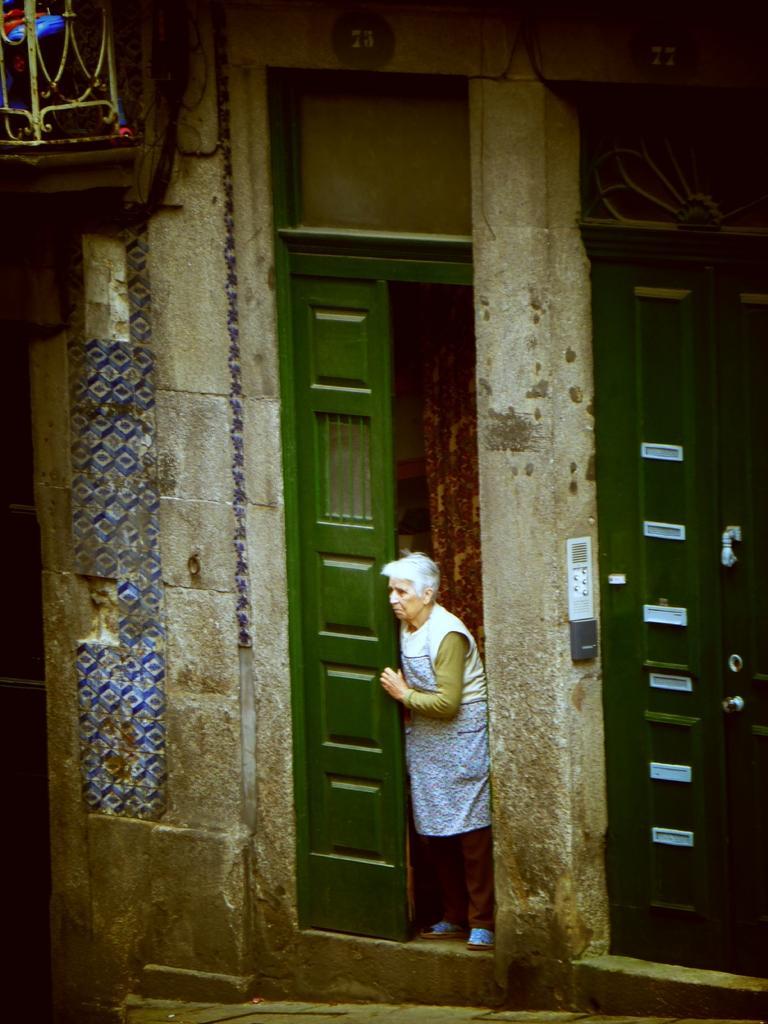In one or two sentences, can you explain what this image depicts? In this image I can see two green color doors to a wall. Beside the door there is a woman standing and looking at the left side. In the top left there is a wooden object. 